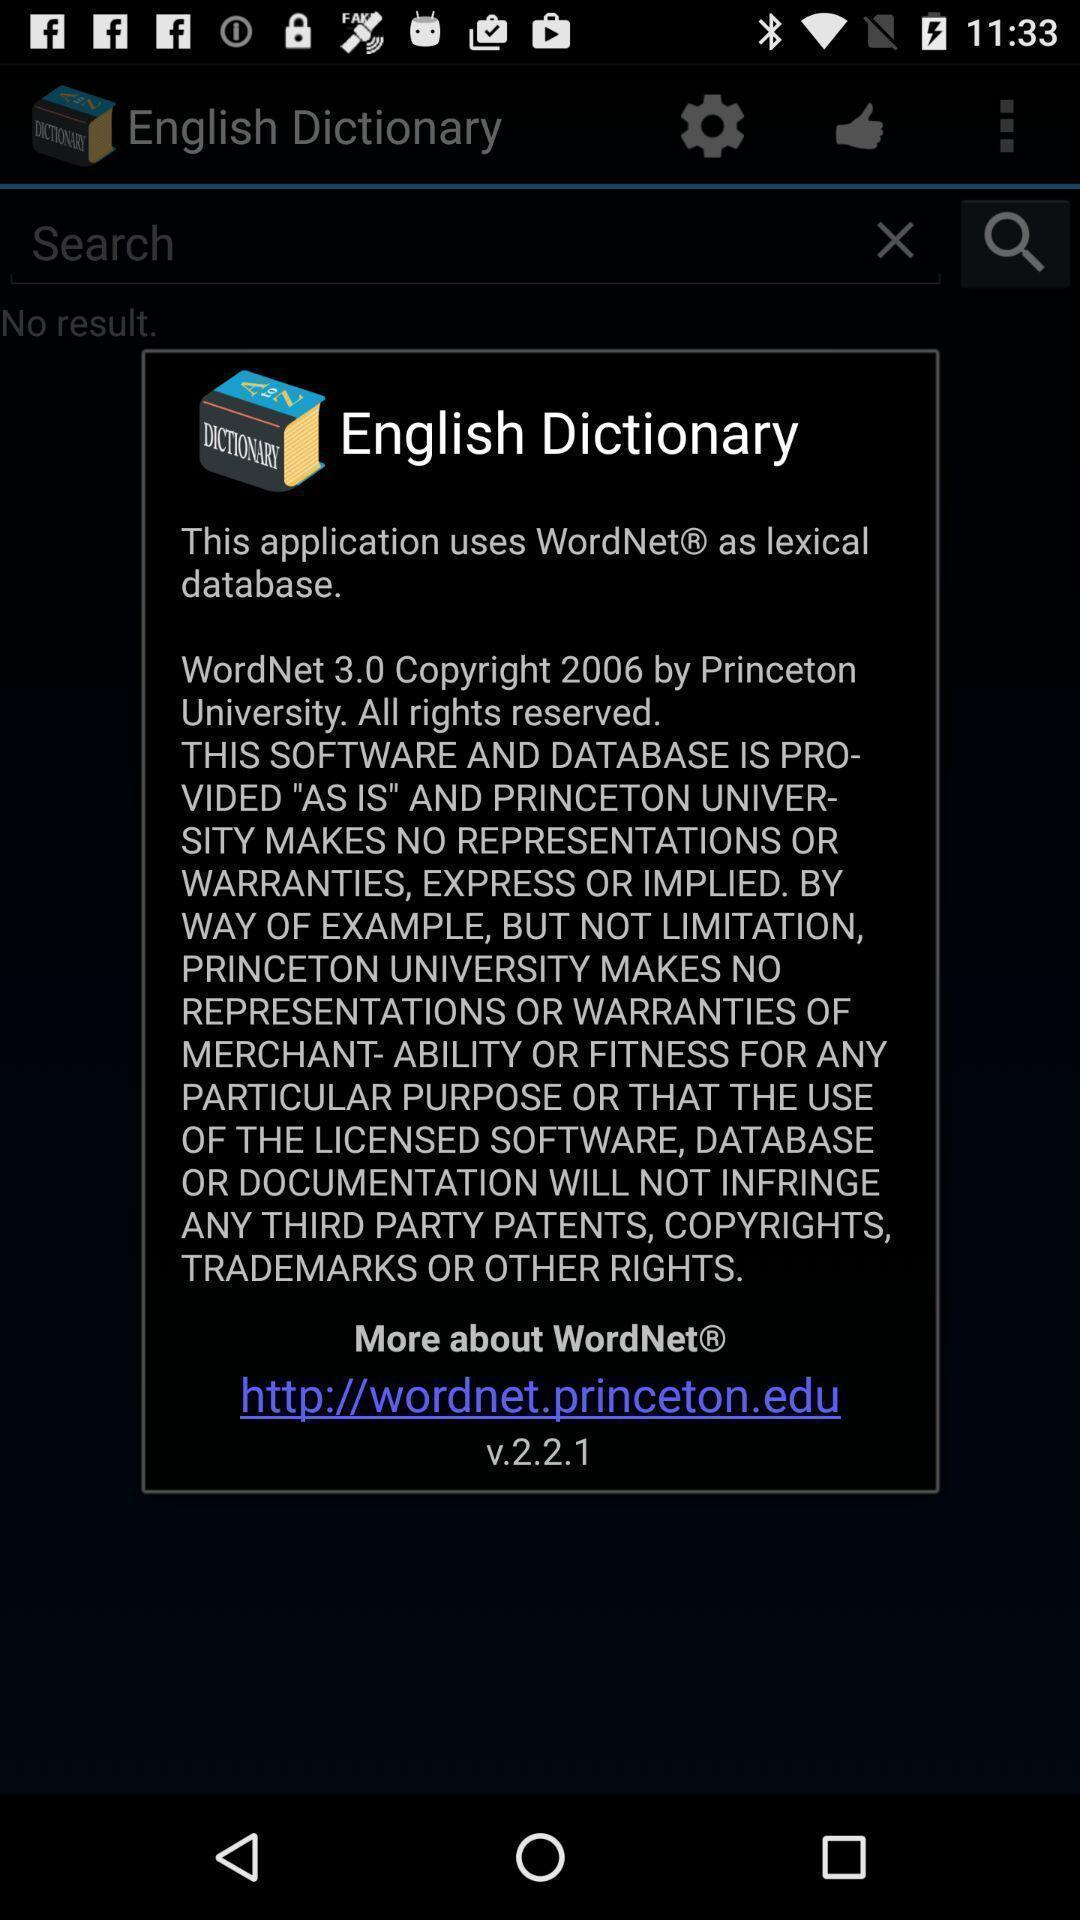Explain the elements present in this screenshot. Pop-up to know the version about application. 